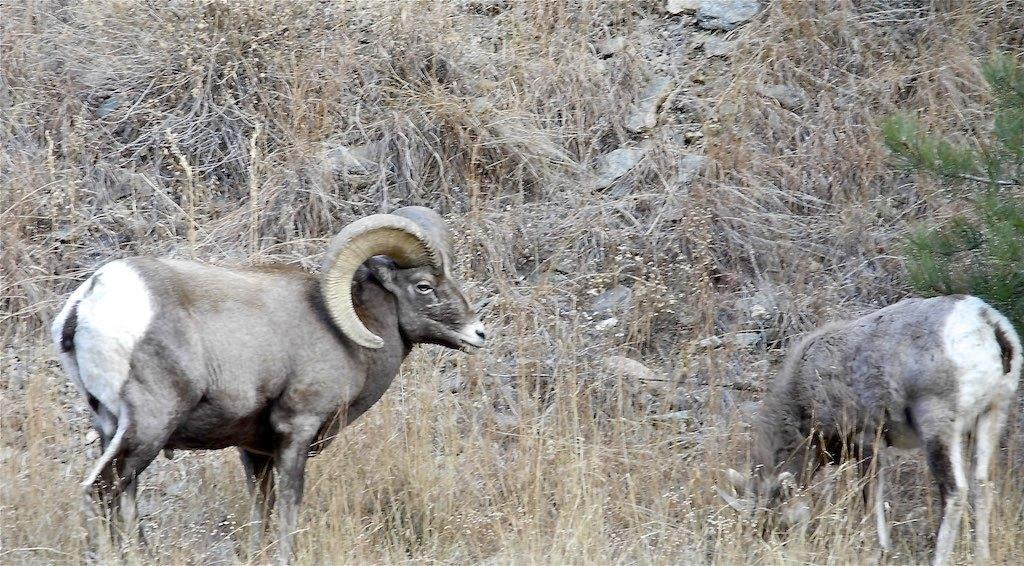How many animals can be seen in the image? There are two animals in the image. What is the setting in which the animals are located? The animals are standing in the grass. What can be seen on the right side of the image? There is a branch of a tree on the right side of the image. What type of vegetation is present on the ground in the image? There is dried grass on the ground in the image. What type of sail can be seen in the image? There is no sail present in the image. How many units are visible in the image? The concept of "units" is not mentioned or relevant to the image, so it cannot be determined from the image. 